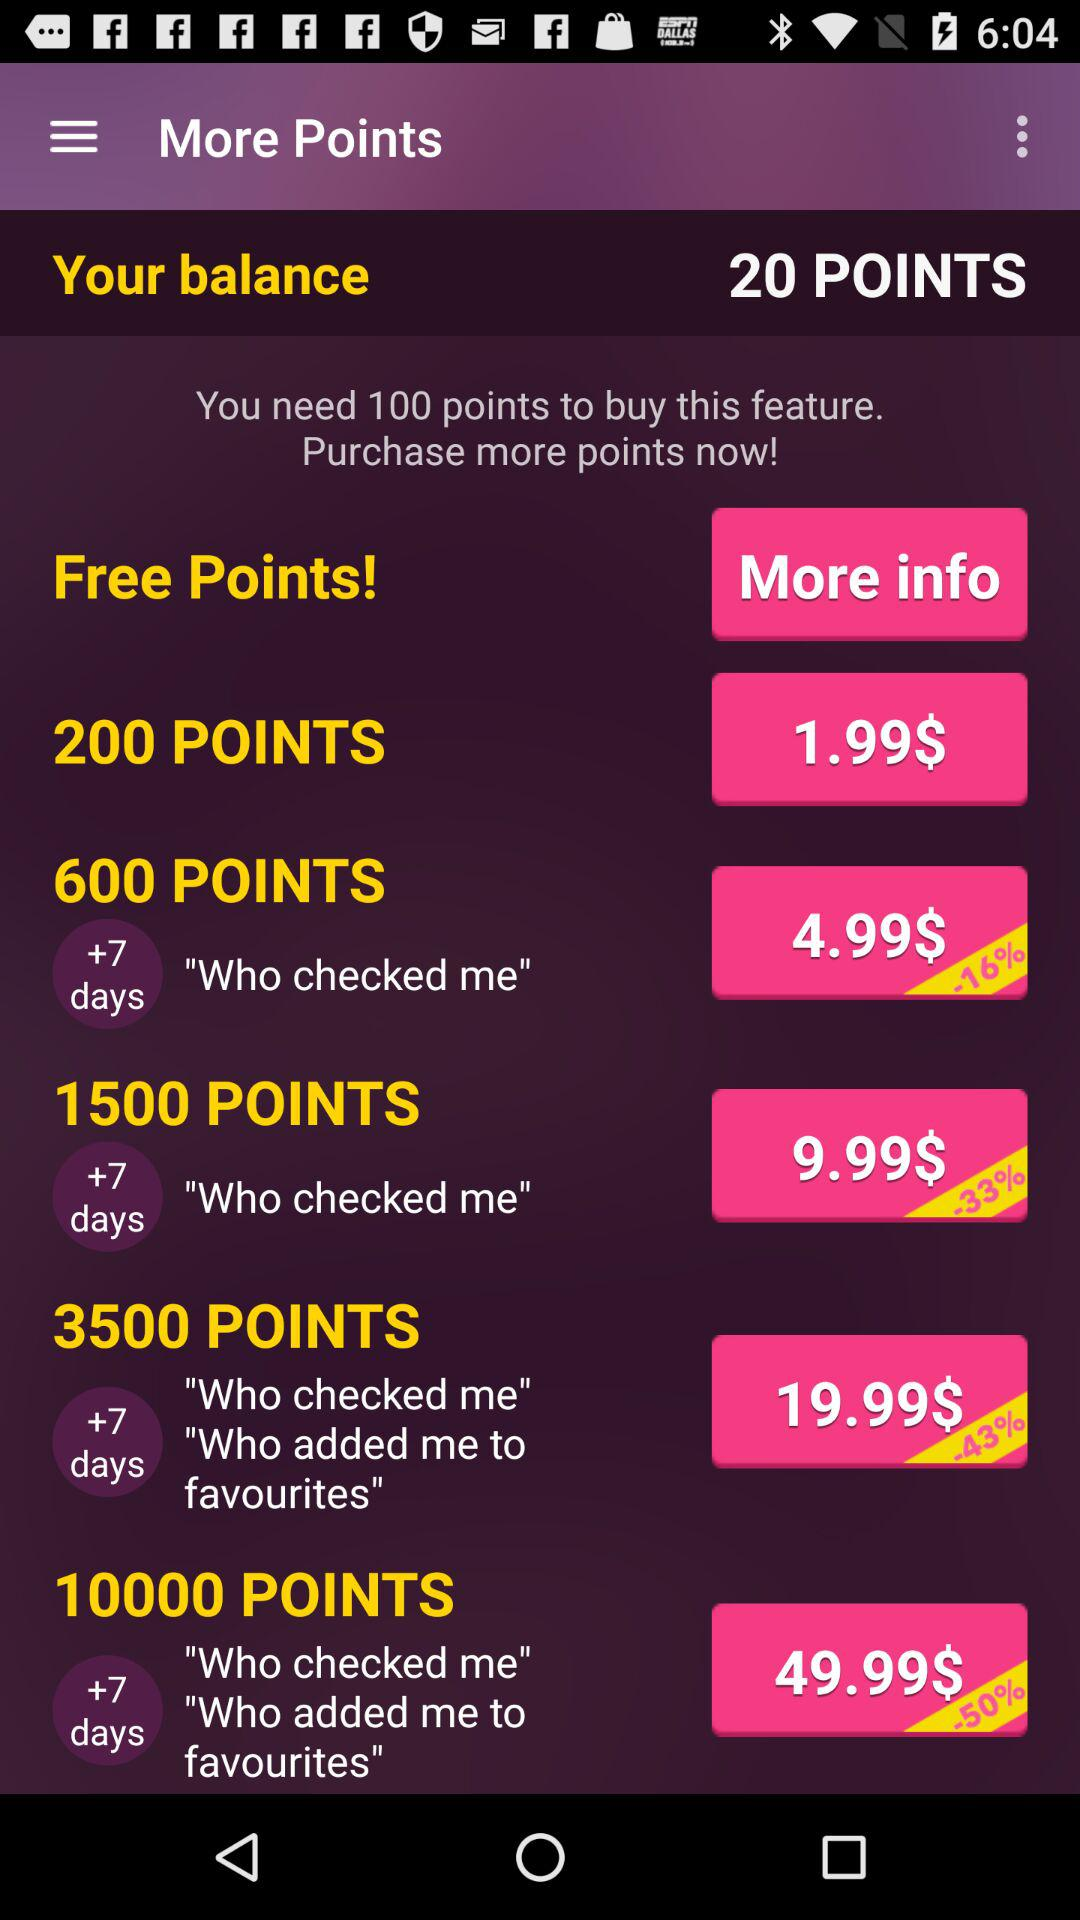How many points do I have?
Answer the question using a single word or phrase. 20 